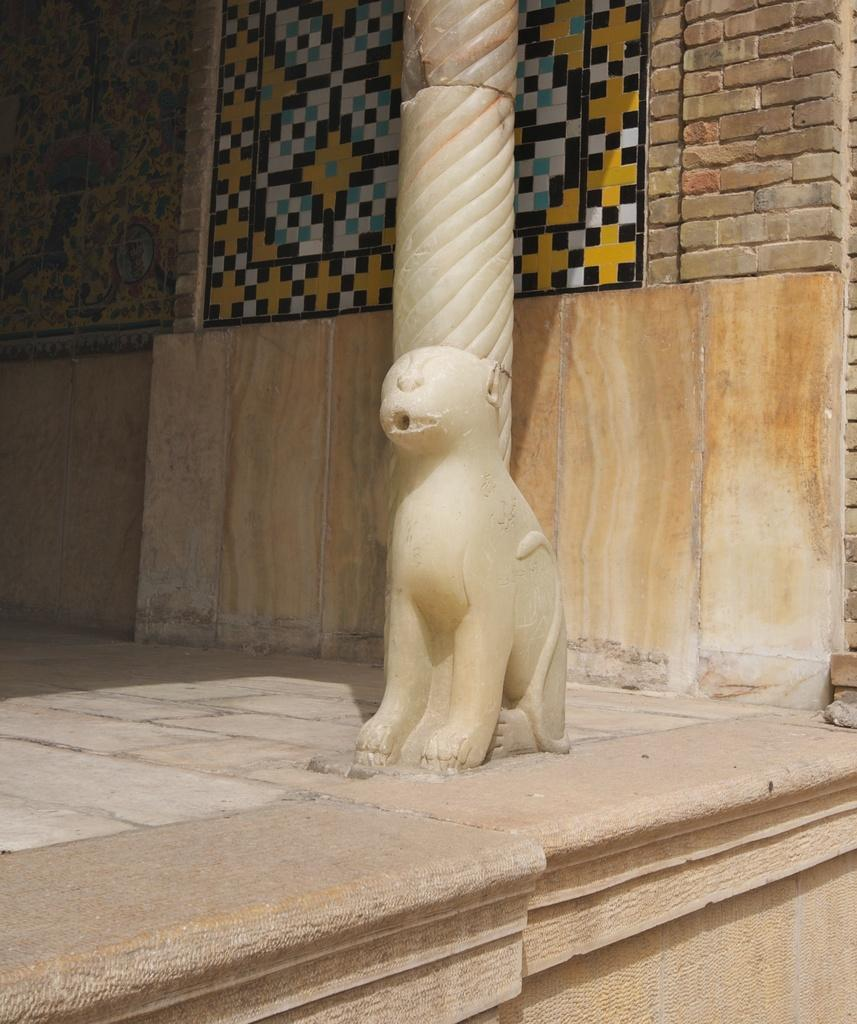What is the main subject in the front of the image? There is a sculpture in the front of the image. What other architectural feature can be seen in the image? There is a pillar in the image. What type of artwork is visible on the wall in the background? There are paintings on the wall in the background of the image. What type of beam is holding up the ceiling in the image? There is no beam visible in the image; it only shows a sculpture, a pillar, and paintings on the wall. How many balls are present in the image? There are no balls present in the image. 